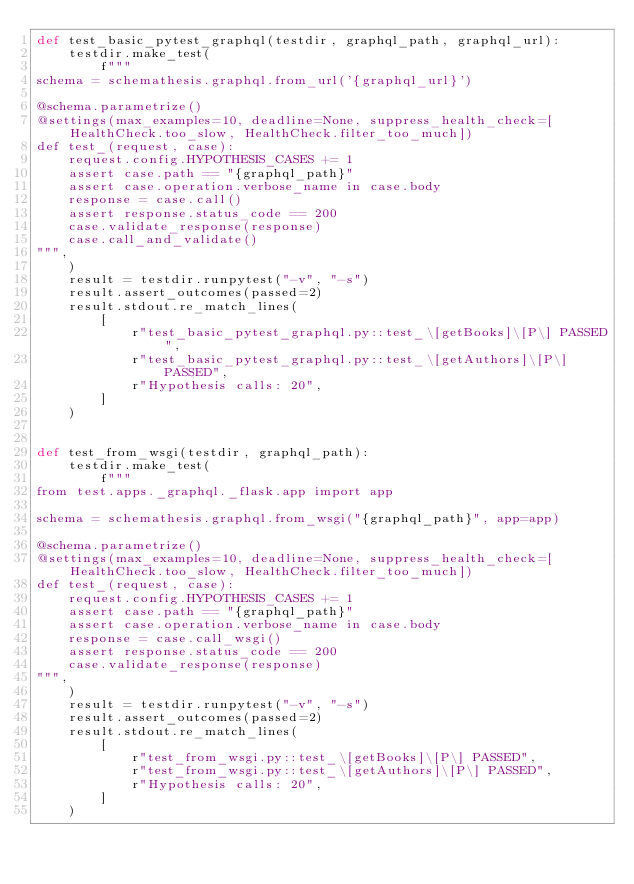<code> <loc_0><loc_0><loc_500><loc_500><_Python_>def test_basic_pytest_graphql(testdir, graphql_path, graphql_url):
    testdir.make_test(
        f"""
schema = schemathesis.graphql.from_url('{graphql_url}')

@schema.parametrize()
@settings(max_examples=10, deadline=None, suppress_health_check=[HealthCheck.too_slow, HealthCheck.filter_too_much])
def test_(request, case):
    request.config.HYPOTHESIS_CASES += 1
    assert case.path == "{graphql_path}"
    assert case.operation.verbose_name in case.body
    response = case.call()
    assert response.status_code == 200
    case.validate_response(response)
    case.call_and_validate()
""",
    )
    result = testdir.runpytest("-v", "-s")
    result.assert_outcomes(passed=2)
    result.stdout.re_match_lines(
        [
            r"test_basic_pytest_graphql.py::test_\[getBooks]\[P\] PASSED",
            r"test_basic_pytest_graphql.py::test_\[getAuthors]\[P\] PASSED",
            r"Hypothesis calls: 20",
        ]
    )


def test_from_wsgi(testdir, graphql_path):
    testdir.make_test(
        f"""
from test.apps._graphql._flask.app import app

schema = schemathesis.graphql.from_wsgi("{graphql_path}", app=app)

@schema.parametrize()
@settings(max_examples=10, deadline=None, suppress_health_check=[HealthCheck.too_slow, HealthCheck.filter_too_much])
def test_(request, case):
    request.config.HYPOTHESIS_CASES += 1
    assert case.path == "{graphql_path}"
    assert case.operation.verbose_name in case.body
    response = case.call_wsgi()
    assert response.status_code == 200
    case.validate_response(response)
""",
    )
    result = testdir.runpytest("-v", "-s")
    result.assert_outcomes(passed=2)
    result.stdout.re_match_lines(
        [
            r"test_from_wsgi.py::test_\[getBooks]\[P\] PASSED",
            r"test_from_wsgi.py::test_\[getAuthors]\[P\] PASSED",
            r"Hypothesis calls: 20",
        ]
    )
</code> 